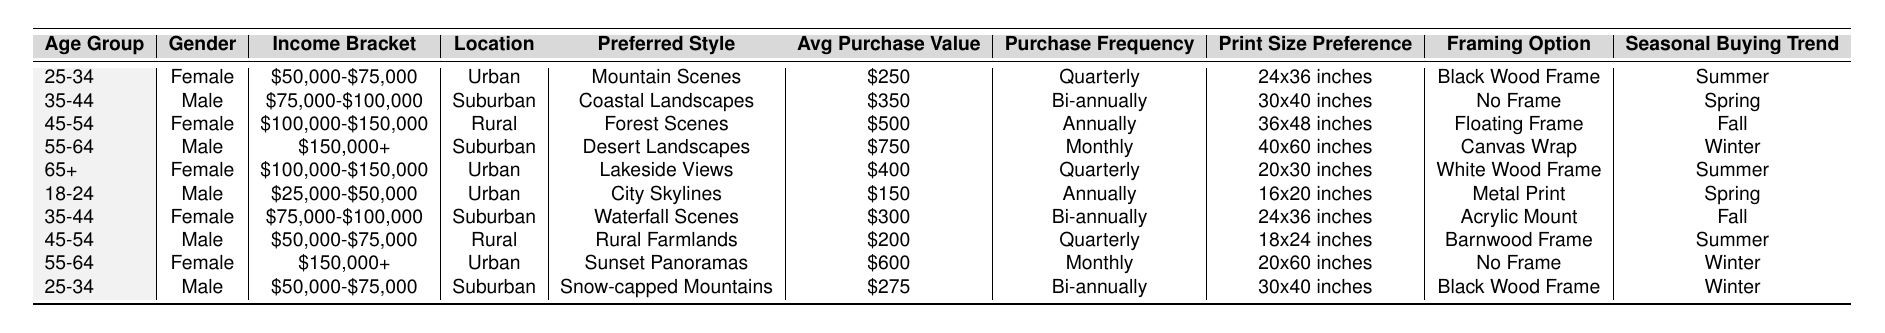What is the preferred style of the youngest age group? The youngest age group is 18-24, and their preferred style is "City Skylines" as seen in the table under that age group.
Answer: City Skylines How often do males aged 55-64 make purchases? Referring to the table, the males aged 55-64 have a purchase frequency of "Monthly".
Answer: Monthly What is the average purchase value for females? To find the average, we sum the purchase values for females: $250, $500, $400, and $600, which equals $1,950. Dividing by the four entries gives $1,950 / 4 = $487.50.
Answer: $487.50 Which age group prefers "Desert Landscapes"? From the table, "Desert Landscapes" is preferred by the 55-64 age group.
Answer: 55-64 Is there a seasonal trend for males aged 35-44? The table indicates that males aged 35-44 have a seasonal buying trend in Spring. Therefore, it is true that they have a seasonal trend.
Answer: Yes How many different framing options are mentioned for female customers? The table lists four different framing options for females: "Black Wood Frame", "Floating Frame", "White Wood Frame", and "No Frame". Thus, there are four options.
Answer: Four What is the average print size preference for customers aged 45-54? The print sizes for the 45-54 age group are 36x48 inches and 18x24 inches. Converting these to square inches (36*48 = 1,728 and 18*24 = 432), we sum them (1,728 + 432 = 2,160) and divide by the two options to find an average size of 1,080 square inches.
Answer: 1,080 square inches Which demographics have the highest average purchase value? By reviewing the table, we determine that males aged 55-64 have the highest average purchase value of $750.
Answer: Males aged 55-64 How many age groups purchase landscape photography prints in the Spring? The table shows that two age groups (18-24 male and 35-44 female) have a seasonal buying trend in Spring, indicating that two demographics purchase in this season.
Answer: Two What is the income bracket of the 45-54-aged female customer? In the table, the income bracket listed for the 45-54 aged female is "$100,000-$150,000".
Answer: $100,000-$150,000 